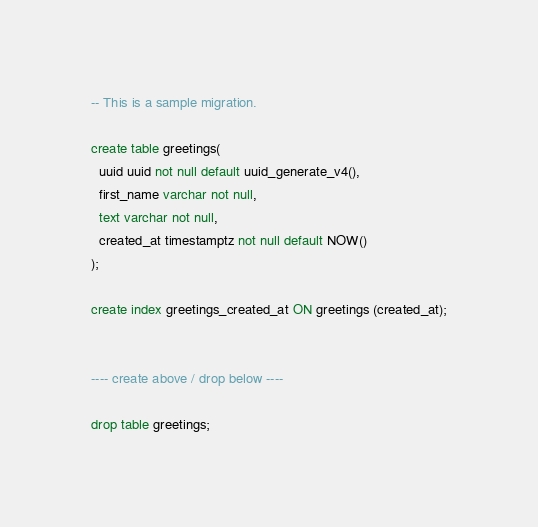Convert code to text. <code><loc_0><loc_0><loc_500><loc_500><_SQL_>-- This is a sample migration.

create table greetings(
  uuid uuid not null default uuid_generate_v4(),
  first_name varchar not null,
  text varchar not null,
  created_at timestamptz not null default NOW()
);

create index greetings_created_at ON greetings (created_at);


---- create above / drop below ----

drop table greetings;
</code> 